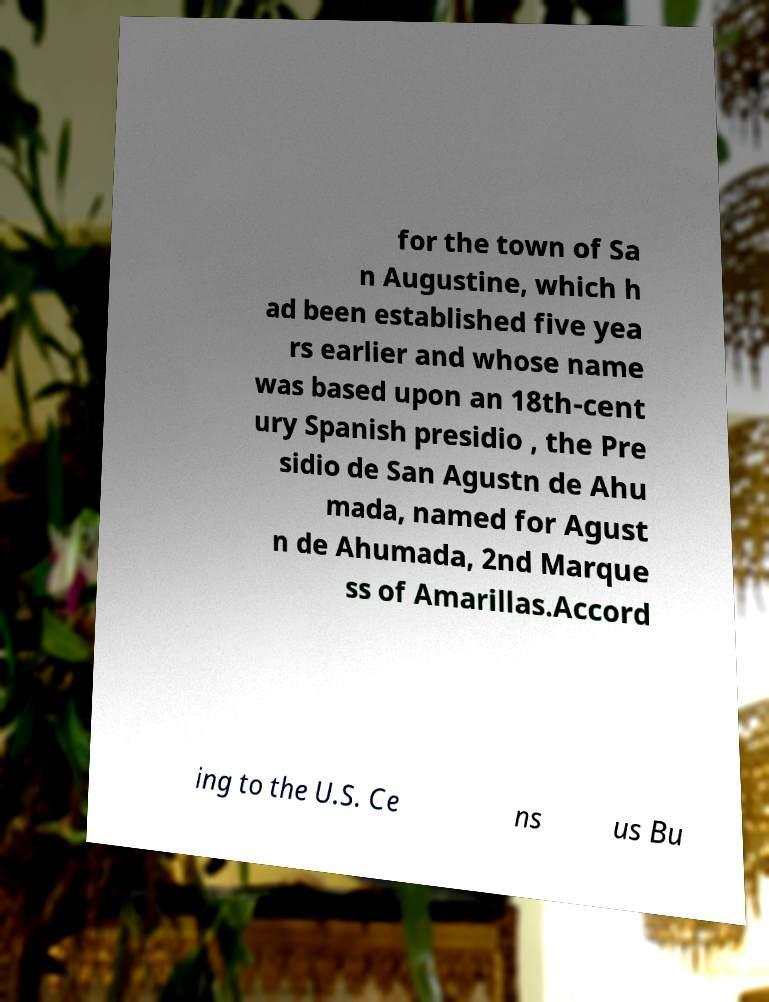There's text embedded in this image that I need extracted. Can you transcribe it verbatim? for the town of Sa n Augustine, which h ad been established five yea rs earlier and whose name was based upon an 18th-cent ury Spanish presidio , the Pre sidio de San Agustn de Ahu mada, named for Agust n de Ahumada, 2nd Marque ss of Amarillas.Accord ing to the U.S. Ce ns us Bu 